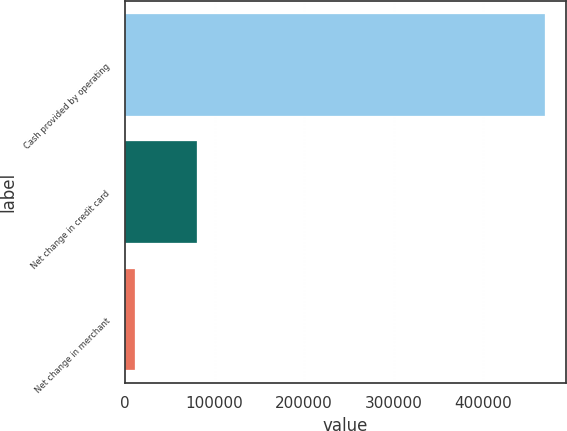<chart> <loc_0><loc_0><loc_500><loc_500><bar_chart><fcel>Cash provided by operating<fcel>Net change in credit card<fcel>Net change in merchant<nl><fcel>468780<fcel>80890<fcel>11043<nl></chart> 